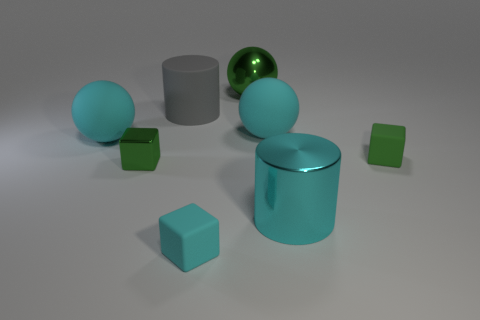Subtract all big cyan spheres. How many spheres are left? 1 Subtract all cyan balls. How many balls are left? 1 Subtract all cylinders. How many objects are left? 6 Subtract 3 blocks. How many blocks are left? 0 Add 1 tiny green shiny objects. How many objects exist? 9 Subtract all brown balls. How many green cubes are left? 2 Subtract all large green balls. Subtract all small cyan cubes. How many objects are left? 6 Add 6 tiny rubber things. How many tiny rubber things are left? 8 Add 4 cyan cubes. How many cyan cubes exist? 5 Subtract 0 purple cylinders. How many objects are left? 8 